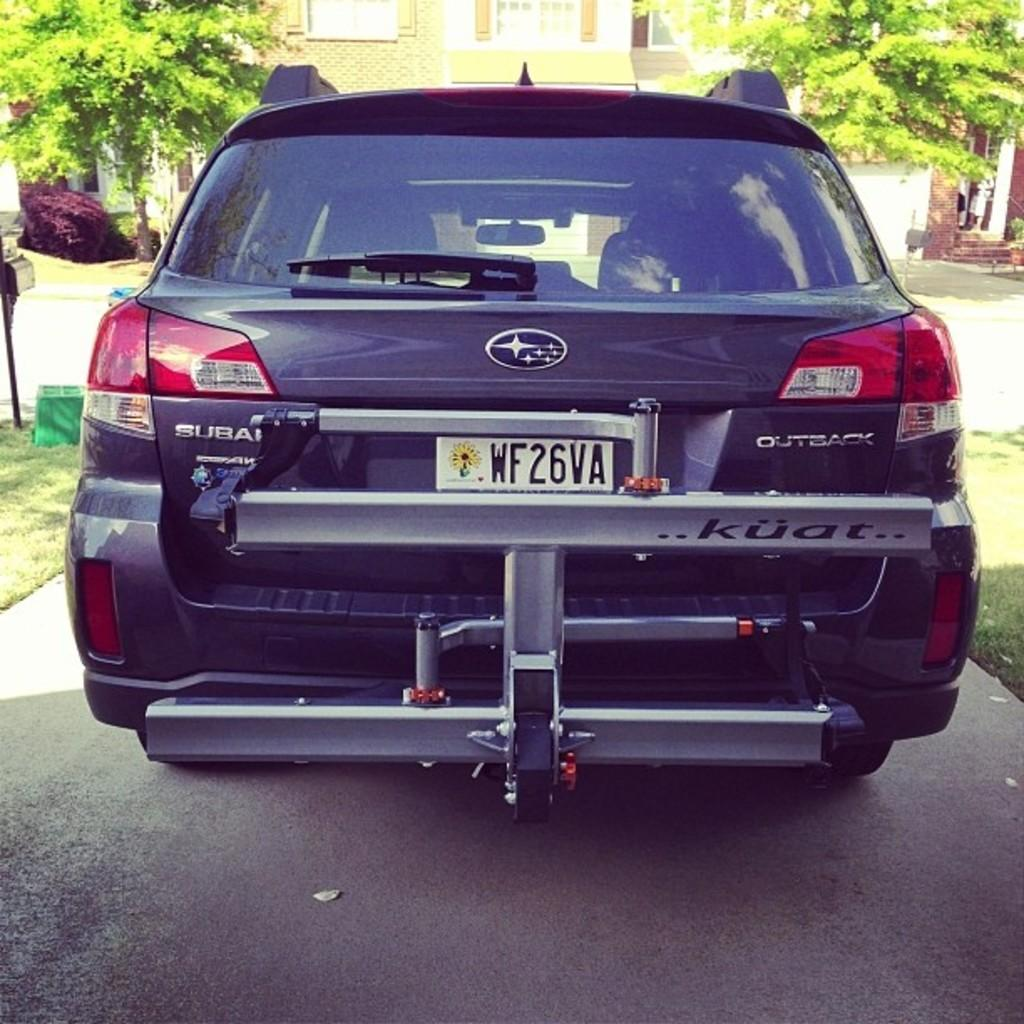Provide a one-sentence caption for the provided image. a license plate that has wf2 on it. 